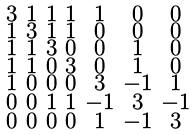Convert formula to latex. <formula><loc_0><loc_0><loc_500><loc_500>\begin{smallmatrix} 3 & 1 & 1 & 1 & 1 & 0 & 0 \\ 1 & 3 & 1 & 1 & 0 & 0 & 0 \\ 1 & 1 & 3 & 0 & 0 & 1 & 0 \\ 1 & 1 & 0 & 3 & 0 & 1 & 0 \\ 1 & 0 & 0 & 0 & 3 & - 1 & 1 \\ 0 & 0 & 1 & 1 & - 1 & 3 & - 1 \\ 0 & 0 & 0 & 0 & 1 & - 1 & 3 \end{smallmatrix}</formula> 